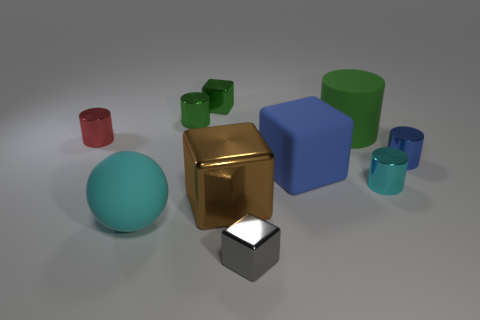What number of other objects are the same color as the large rubber cylinder?
Offer a very short reply. 2. The small metallic object that is on the left side of the big green cylinder and in front of the blue matte block is what color?
Make the answer very short. Gray. There is a metal cylinder that is behind the small metallic cylinder left of the big rubber object that is to the left of the large matte cube; what is its size?
Your answer should be compact. Small. What number of things are cylinders behind the small blue metallic cylinder or blocks to the left of the blue block?
Offer a terse response. 6. What shape is the cyan metallic thing?
Make the answer very short. Cylinder. What number of other objects are the same material as the small blue cylinder?
Provide a short and direct response. 6. There is a green matte object that is the same shape as the small red metal thing; what size is it?
Ensure brevity in your answer.  Large. What is the material of the green cylinder to the right of the tiny metallic thing behind the shiny cylinder that is behind the big green cylinder?
Your response must be concise. Rubber. Are there any large gray metallic blocks?
Your response must be concise. No. Does the big matte cylinder have the same color as the metallic cube that is behind the brown metallic object?
Offer a very short reply. Yes. 